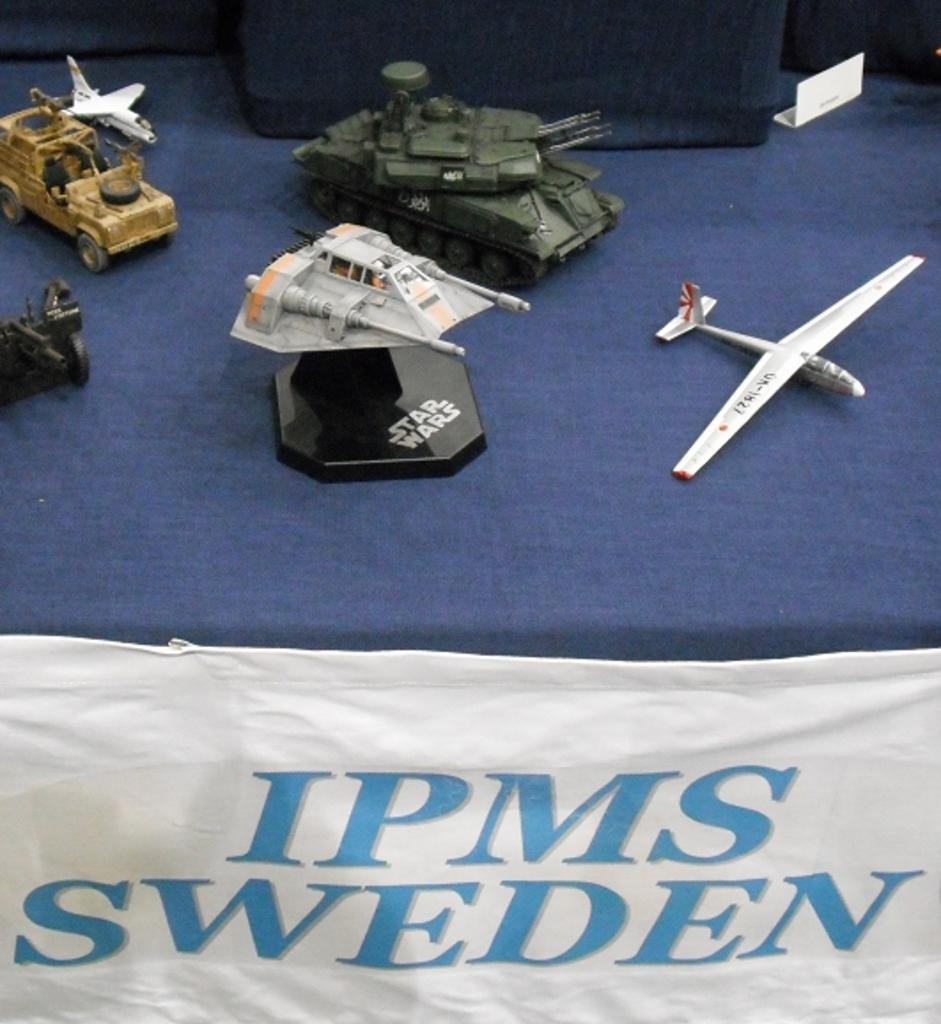Can you describe this image briefly? In this picture I can see toy vehicles on an object and there is a cloth. 